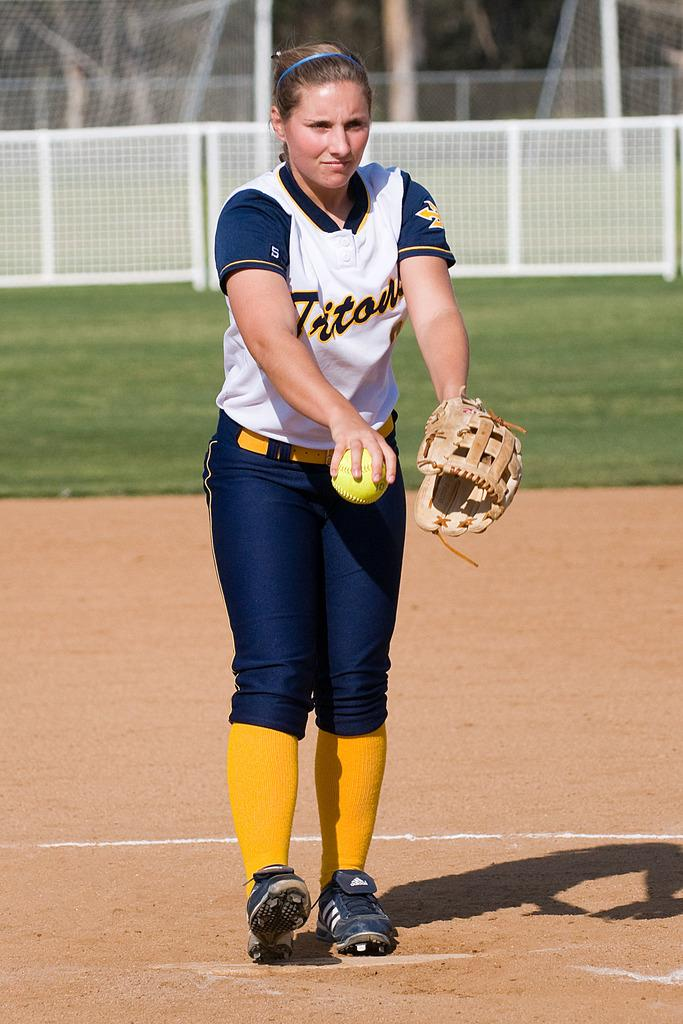Who is present in the image? There is a woman in the image. What is the woman holding in the image? The woman is holding a ball. What is the woman wearing on her hand? The woman is wearing a glove. What type of surface can be seen in the image? There is ground visible in the image. What can be seen in the background of the image? There is mesh, poles, and grass in the background of the image. What type of cushion is being used by the police in the image? There is no police or cushion present in the image. 